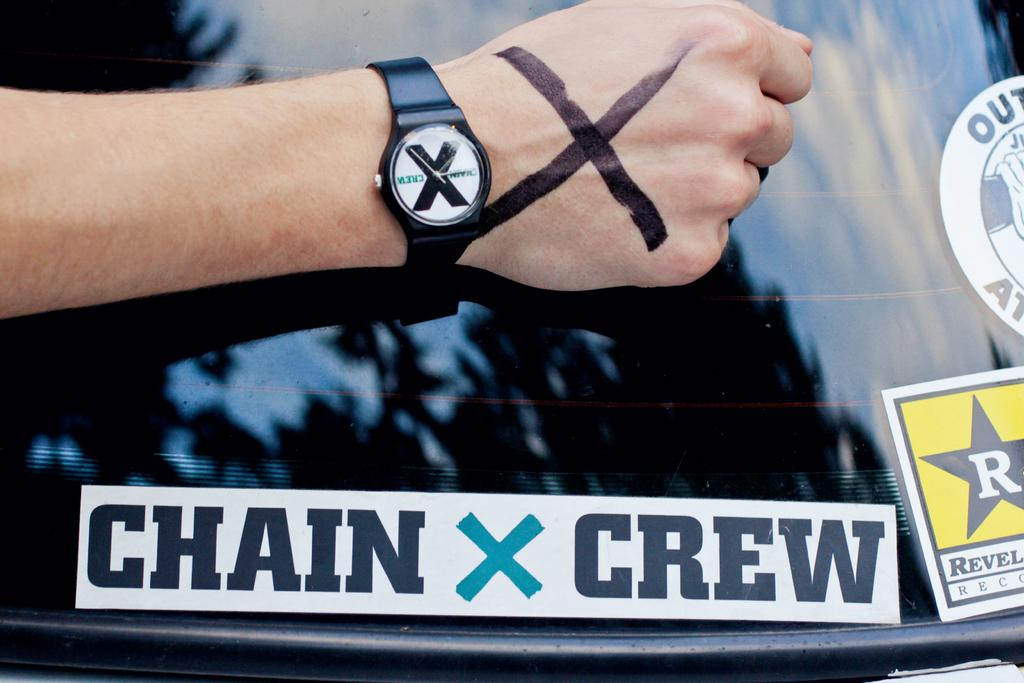<image>
Render a clear and concise summary of the photo. A person wearing a Chain X Crew black wristwatch. 